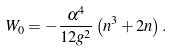Convert formula to latex. <formula><loc_0><loc_0><loc_500><loc_500>W _ { 0 } = - \frac { \alpha ^ { 4 } } { 1 2 g ^ { 2 } } \left ( n ^ { 3 } + 2 n \right ) .</formula> 